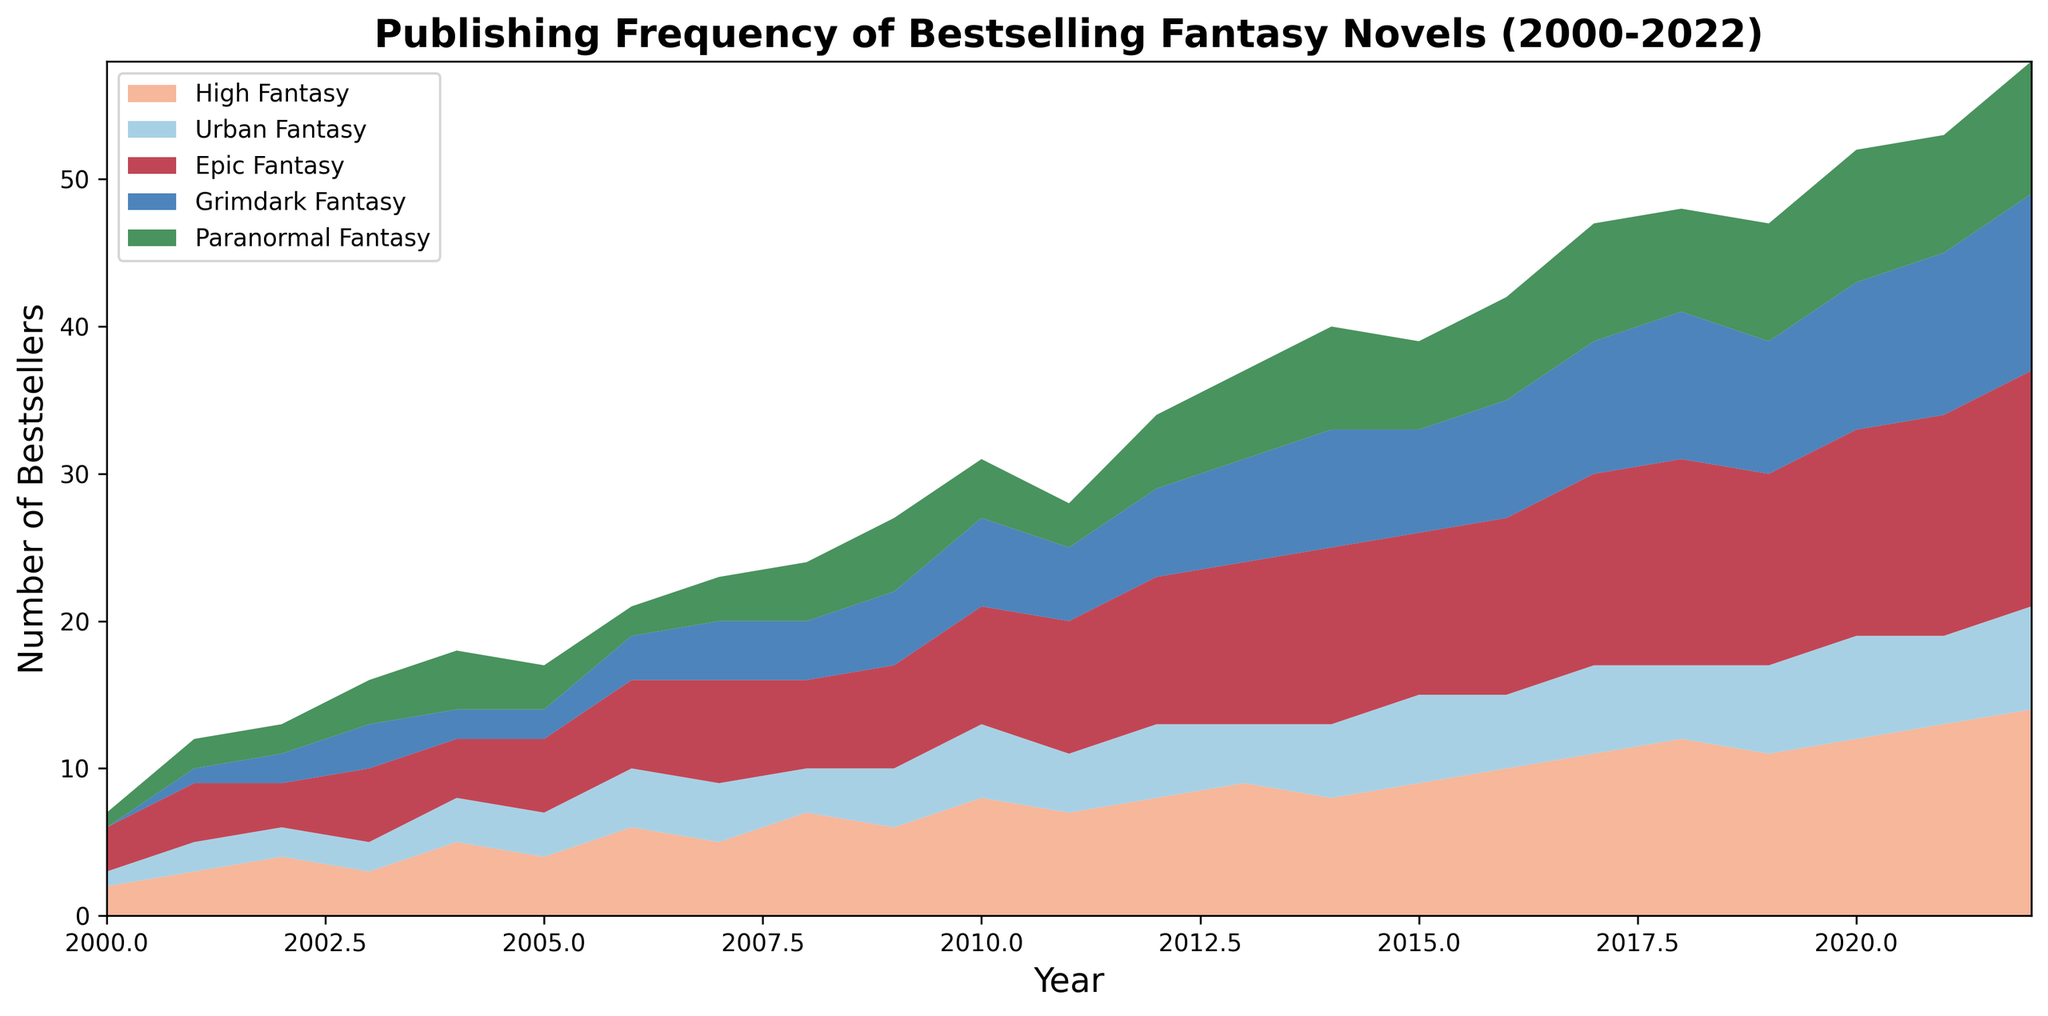What is the sub-genre with the highest frequency of bestsellers in 2022? By examining the far right of the chart for the year 2022, we see that "Epic Fantasy" reaches the highest point compared to all other sub-genres.
Answer: Epic Fantasy Which sub-genre experienced the most significant increase from 2000 to 2022? By comparing the heights of the areas between 2000 and 2022, "Epic Fantasy" shows the largest vertical increase, indicating the most significant rise in frequency over the period.
Answer: Epic Fantasy How many bestsellers were published in total in 2012 across all sub-genres? By looking at the stacked areas for the year 2012, we see that each sub-genre contributes to a total number of bestsellers. Sum up the values for High Fantasy (8), Urban Fantasy (5), Epic Fantasy (10), Grimdark Fantasy (6), and Paranormal Fantasy (5) to get the total.
Answer: 34 Which sub-genre had the fewest bestsellers in 2010? For 2010, we compare the heights of the areas. "Grimdark Fantasy" appears smaller than the other sub-genres, meaning it had the fewest bestsellers.
Answer: Grimdark Fantasy Between which years did "Urban Fantasy" experience its largest increase in bestsellers? By focusing on the light blue section representing "Urban Fantasy," the most substantial vertical increase occurs between 2000 and 2010, with a clear upward slope.
Answer: 2000 and 2010 Which two sub-genres had equal numbers of bestsellers in 2005? Referring to the area chart in 2005, "High Fantasy" and "Epic Fantasy" both seem to occupy equal heights. The numerical data confirms each had 5 bestsellers.
Answer: High Fantasy and Epic Fantasy What was the trend of "High Fantasy" bestsellers between 2018 and 2022? By following the striped pattern for "High Fantasy" between 2018 and 2022, we see a consistent upward trajectory across these years.
Answer: Increasing From 2000 to 2022, which sub-genre showed the most variability in publishing frequency? Observe the overall fluctuation in height for each sub-genre. "Grimdark Fantasy" shows notable peaks and valleys, indicating the highest variability.
Answer: Grimdark Fantasy In which year did "Paranormal Fantasy" achieve its highest number of bestsellers? Examine the green section of the chart, noting its highest point, which appears in 2020.
Answer: 2020 Between 2000 and 2011, did "High Fantasy" or "Urban Fantasy" have more years with higher publishing frequencies? By comparing the two areas from 2000 to 2011, "High Fantasy" has more years where it takes a distinctly larger space than "Urban Fantasy."
Answer: High Fantasy 